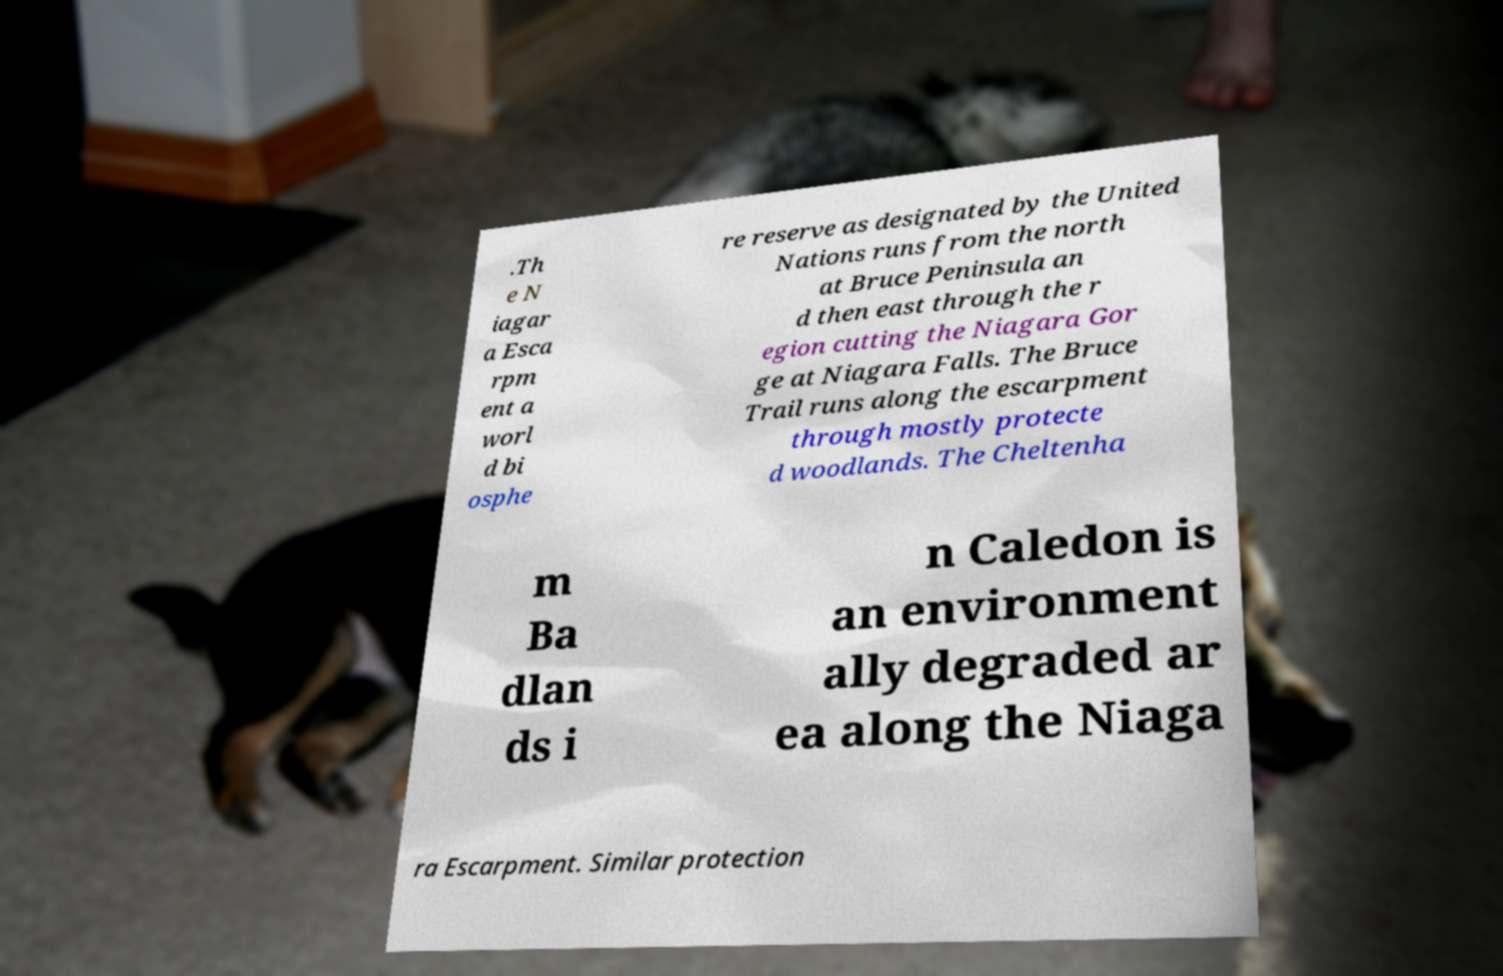For documentation purposes, I need the text within this image transcribed. Could you provide that? .Th e N iagar a Esca rpm ent a worl d bi osphe re reserve as designated by the United Nations runs from the north at Bruce Peninsula an d then east through the r egion cutting the Niagara Gor ge at Niagara Falls. The Bruce Trail runs along the escarpment through mostly protecte d woodlands. The Cheltenha m Ba dlan ds i n Caledon is an environment ally degraded ar ea along the Niaga ra Escarpment. Similar protection 